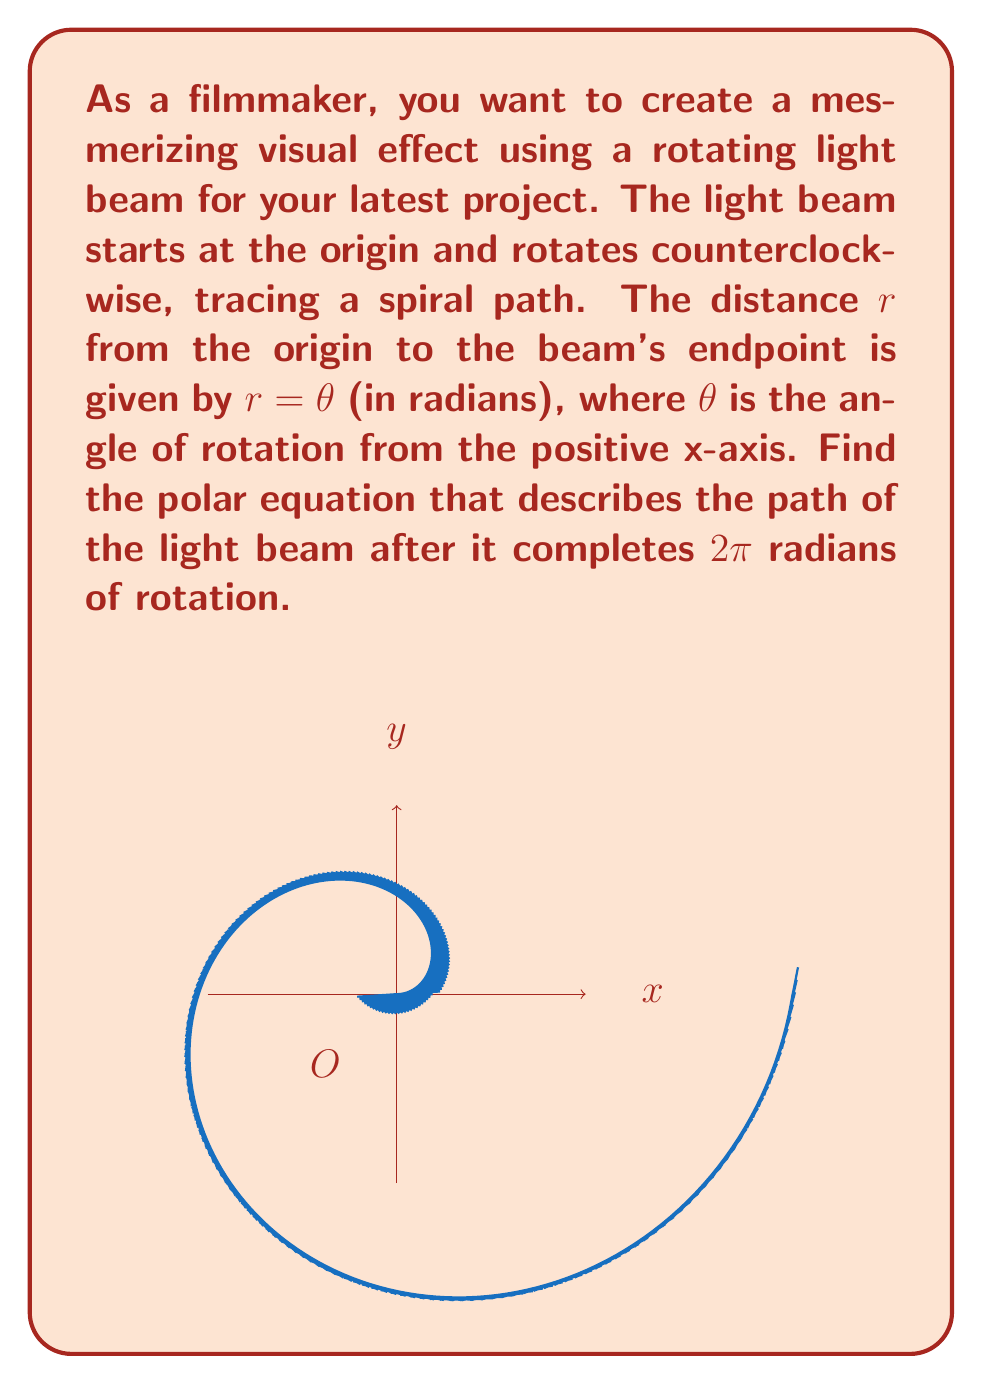What is the answer to this math problem? Let's approach this step-by-step:

1) We are given that the distance $r$ from the origin to the beam's endpoint is equal to the angle $\theta$ in radians:

   $r = \theta$

2) This equation already describes the spiral path of the light beam in polar coordinates.

3) However, we need to consider the constraint that the beam completes 2π radians of rotation.

4) In polar coordinates, an angle of 2π radians represents a full rotation. After this, the pattern would repeat.

5) To represent this mathematically, we can use the modulo operation. In polar coordinates, this is often written using brackets:

   $r = [\theta]_{2\pi}$

6) This equation means that $r$ is equal to $\theta$ modulo 2π, ensuring that the angle always stays within the range [0, 2π).

7) The modulo operation in this context can be thought of as "wrapping" the angle around the origin, creating the spiral effect that repeats every 2π radians.

Therefore, the polar equation describing the path of the light beam after it completes 2π radians of rotation is $r = [\theta]_{2\pi}$.
Answer: $r = [\theta]_{2\pi}$ 